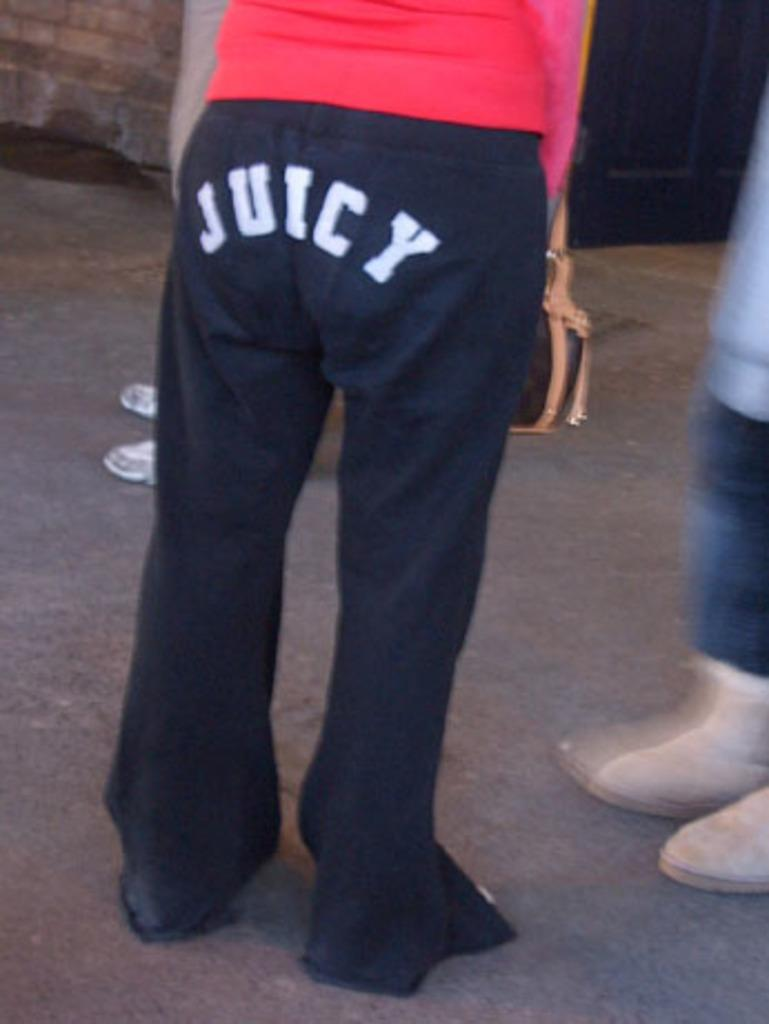<image>
Provide a brief description of the given image. Person is wearing some juicy pants standing in a line 